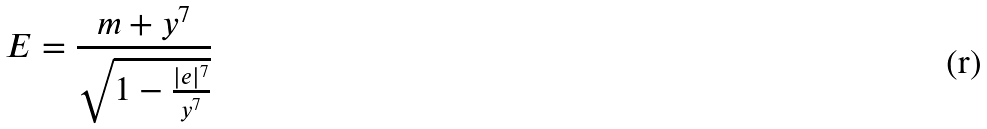<formula> <loc_0><loc_0><loc_500><loc_500>E = \frac { m + y ^ { 7 } } { \sqrt { 1 - \frac { | e | ^ { 7 } } { y ^ { 7 } } } }</formula> 